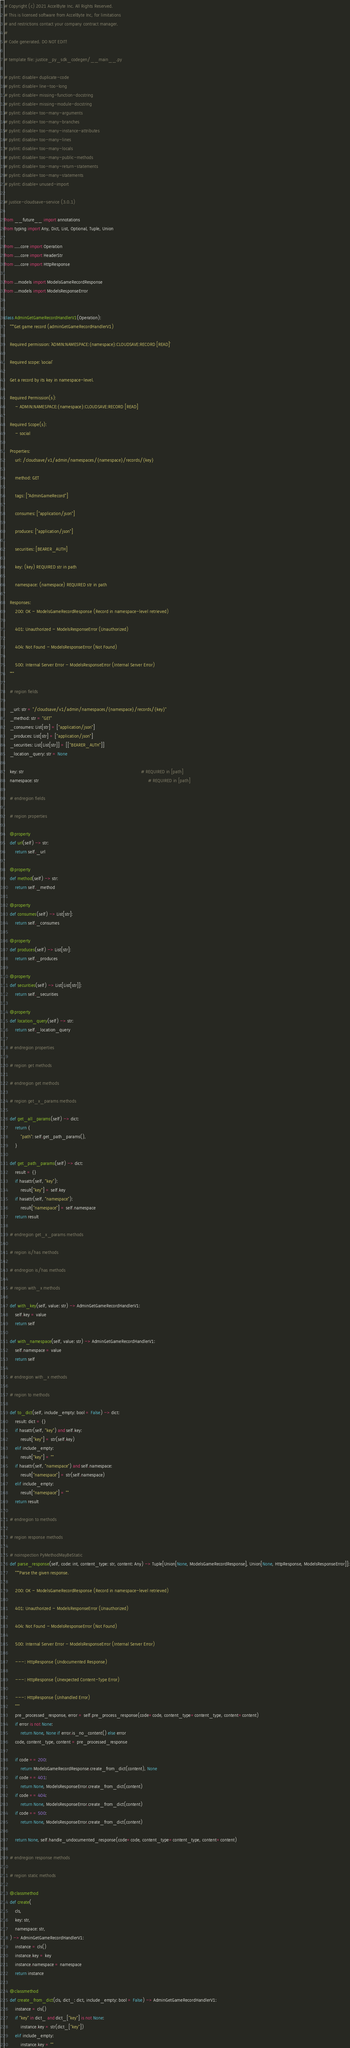Convert code to text. <code><loc_0><loc_0><loc_500><loc_500><_Python_># Copyright (c) 2021 AccelByte Inc. All Rights Reserved.
# This is licensed software from AccelByte Inc, for limitations
# and restrictions contact your company contract manager.
# 
# Code generated. DO NOT EDIT!

# template file: justice_py_sdk_codegen/__main__.py

# pylint: disable=duplicate-code
# pylint: disable=line-too-long
# pylint: disable=missing-function-docstring
# pylint: disable=missing-module-docstring
# pylint: disable=too-many-arguments
# pylint: disable=too-many-branches
# pylint: disable=too-many-instance-attributes
# pylint: disable=too-many-lines
# pylint: disable=too-many-locals
# pylint: disable=too-many-public-methods
# pylint: disable=too-many-return-statements
# pylint: disable=too-many-statements
# pylint: disable=unused-import

# justice-cloudsave-service (3.0.1)

from __future__ import annotations
from typing import Any, Dict, List, Optional, Tuple, Union

from .....core import Operation
from .....core import HeaderStr
from .....core import HttpResponse

from ...models import ModelsGameRecordResponse
from ...models import ModelsResponseError


class AdminGetGameRecordHandlerV1(Operation):
    """Get game record (adminGetGameRecordHandlerV1)

    Required permission: `ADMIN:NAMESPACE:{namespace}:CLOUDSAVE:RECORD [READ]`

    Required scope: `social`

    Get a record by its key in namespace-level.

    Required Permission(s):
        - ADMIN:NAMESPACE:{namespace}:CLOUDSAVE:RECORD [READ]

    Required Scope(s):
        - social

    Properties:
        url: /cloudsave/v1/admin/namespaces/{namespace}/records/{key}

        method: GET

        tags: ["AdminGameRecord"]

        consumes: ["application/json"]

        produces: ["application/json"]

        securities: [BEARER_AUTH]

        key: (key) REQUIRED str in path

        namespace: (namespace) REQUIRED str in path

    Responses:
        200: OK - ModelsGameRecordResponse (Record in namespace-level retrieved)

        401: Unauthorized - ModelsResponseError (Unauthorized)

        404: Not Found - ModelsResponseError (Not Found)

        500: Internal Server Error - ModelsResponseError (Internal Server Error)
    """

    # region fields

    _url: str = "/cloudsave/v1/admin/namespaces/{namespace}/records/{key}"
    _method: str = "GET"
    _consumes: List[str] = ["application/json"]
    _produces: List[str] = ["application/json"]
    _securities: List[List[str]] = [["BEARER_AUTH"]]
    _location_query: str = None

    key: str                                                                                       # REQUIRED in [path]
    namespace: str                                                                                 # REQUIRED in [path]

    # endregion fields

    # region properties

    @property
    def url(self) -> str:
        return self._url

    @property
    def method(self) -> str:
        return self._method

    @property
    def consumes(self) -> List[str]:
        return self._consumes

    @property
    def produces(self) -> List[str]:
        return self._produces

    @property
    def securities(self) -> List[List[str]]:
        return self._securities

    @property
    def location_query(self) -> str:
        return self._location_query

    # endregion properties

    # region get methods

    # endregion get methods

    # region get_x_params methods

    def get_all_params(self) -> dict:
        return {
            "path": self.get_path_params(),
        }

    def get_path_params(self) -> dict:
        result = {}
        if hasattr(self, "key"):
            result["key"] = self.key
        if hasattr(self, "namespace"):
            result["namespace"] = self.namespace
        return result

    # endregion get_x_params methods

    # region is/has methods

    # endregion is/has methods

    # region with_x methods

    def with_key(self, value: str) -> AdminGetGameRecordHandlerV1:
        self.key = value
        return self

    def with_namespace(self, value: str) -> AdminGetGameRecordHandlerV1:
        self.namespace = value
        return self

    # endregion with_x methods

    # region to methods

    def to_dict(self, include_empty: bool = False) -> dict:
        result: dict = {}
        if hasattr(self, "key") and self.key:
            result["key"] = str(self.key)
        elif include_empty:
            result["key"] = ""
        if hasattr(self, "namespace") and self.namespace:
            result["namespace"] = str(self.namespace)
        elif include_empty:
            result["namespace"] = ""
        return result

    # endregion to methods

    # region response methods

    # noinspection PyMethodMayBeStatic
    def parse_response(self, code: int, content_type: str, content: Any) -> Tuple[Union[None, ModelsGameRecordResponse], Union[None, HttpResponse, ModelsResponseError]]:
        """Parse the given response.

        200: OK - ModelsGameRecordResponse (Record in namespace-level retrieved)

        401: Unauthorized - ModelsResponseError (Unauthorized)

        404: Not Found - ModelsResponseError (Not Found)

        500: Internal Server Error - ModelsResponseError (Internal Server Error)

        ---: HttpResponse (Undocumented Response)

        ---: HttpResponse (Unexpected Content-Type Error)

        ---: HttpResponse (Unhandled Error)
        """
        pre_processed_response, error = self.pre_process_response(code=code, content_type=content_type, content=content)
        if error is not None:
            return None, None if error.is_no_content() else error
        code, content_type, content = pre_processed_response

        if code == 200:
            return ModelsGameRecordResponse.create_from_dict(content), None
        if code == 401:
            return None, ModelsResponseError.create_from_dict(content)
        if code == 404:
            return None, ModelsResponseError.create_from_dict(content)
        if code == 500:
            return None, ModelsResponseError.create_from_dict(content)

        return None, self.handle_undocumented_response(code=code, content_type=content_type, content=content)

    # endregion response methods

    # region static methods

    @classmethod
    def create(
        cls,
        key: str,
        namespace: str,
    ) -> AdminGetGameRecordHandlerV1:
        instance = cls()
        instance.key = key
        instance.namespace = namespace
        return instance

    @classmethod
    def create_from_dict(cls, dict_: dict, include_empty: bool = False) -> AdminGetGameRecordHandlerV1:
        instance = cls()
        if "key" in dict_ and dict_["key"] is not None:
            instance.key = str(dict_["key"])
        elif include_empty:
            instance.key = ""</code> 